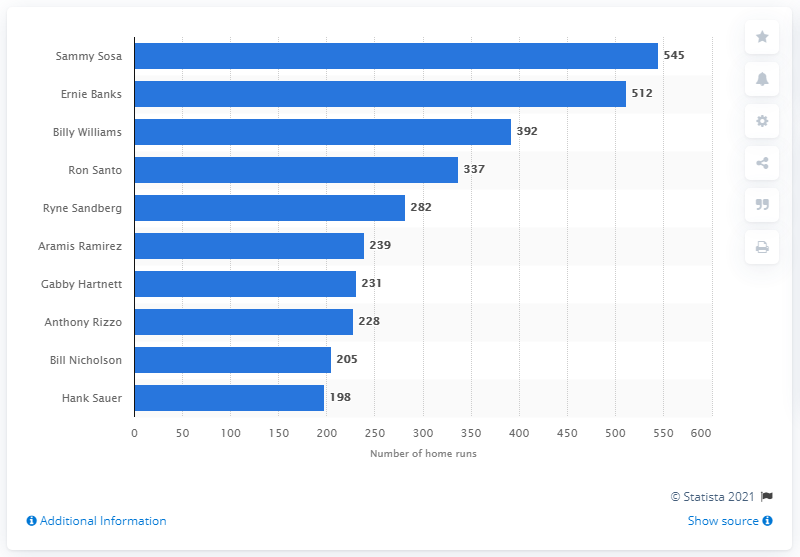Draw attention to some important aspects in this diagram. The person who has hit the most home runs in the history of the Chicago Cubs franchise is Sammy Sosa. Sammy Sosa has hit a total of 545 home runs. 